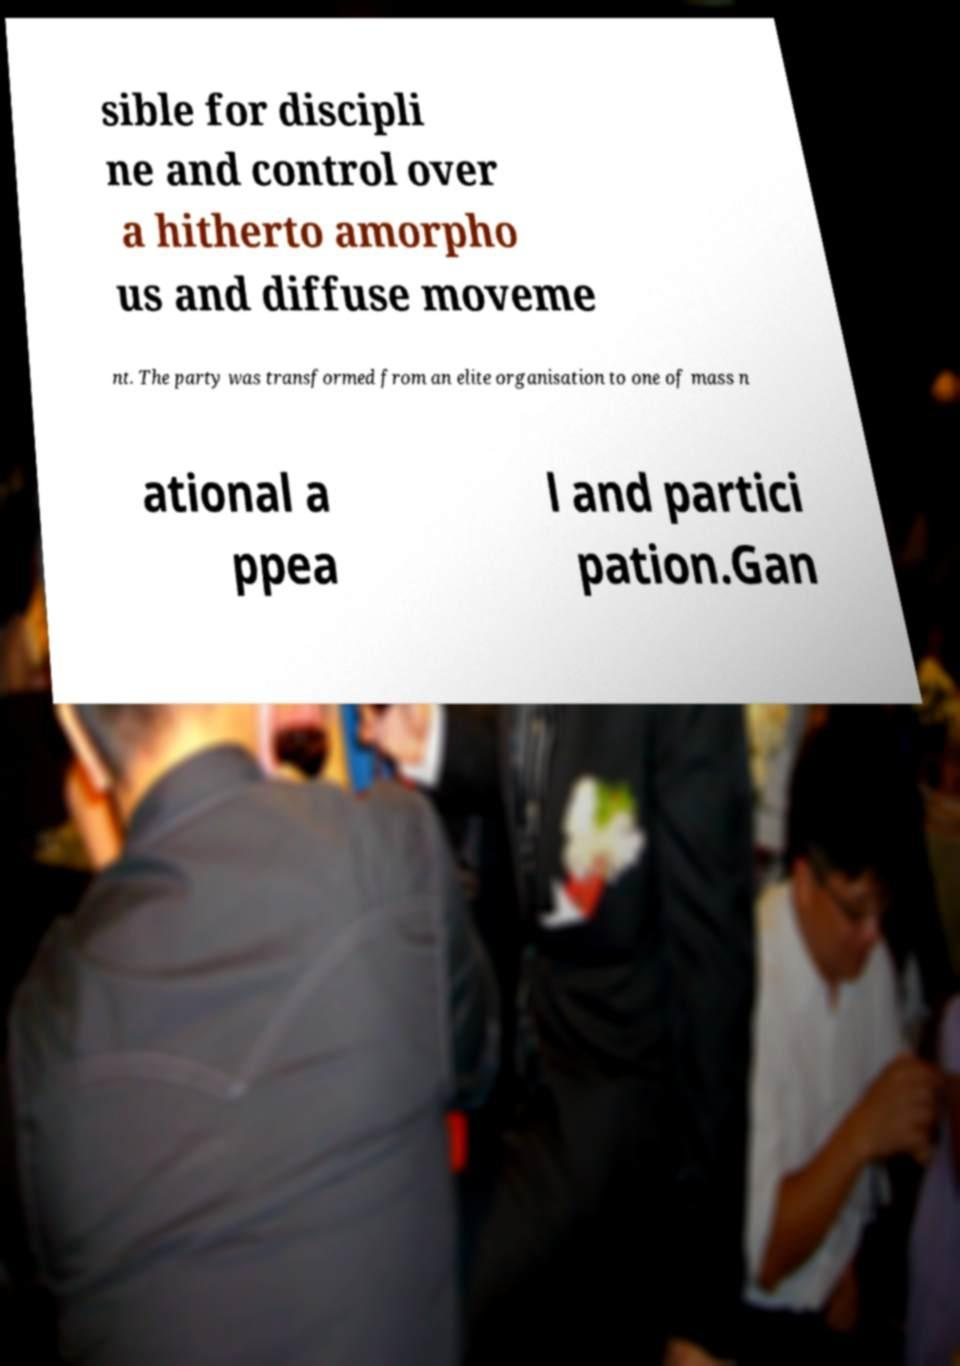What messages or text are displayed in this image? I need them in a readable, typed format. sible for discipli ne and control over a hitherto amorpho us and diffuse moveme nt. The party was transformed from an elite organisation to one of mass n ational a ppea l and partici pation.Gan 